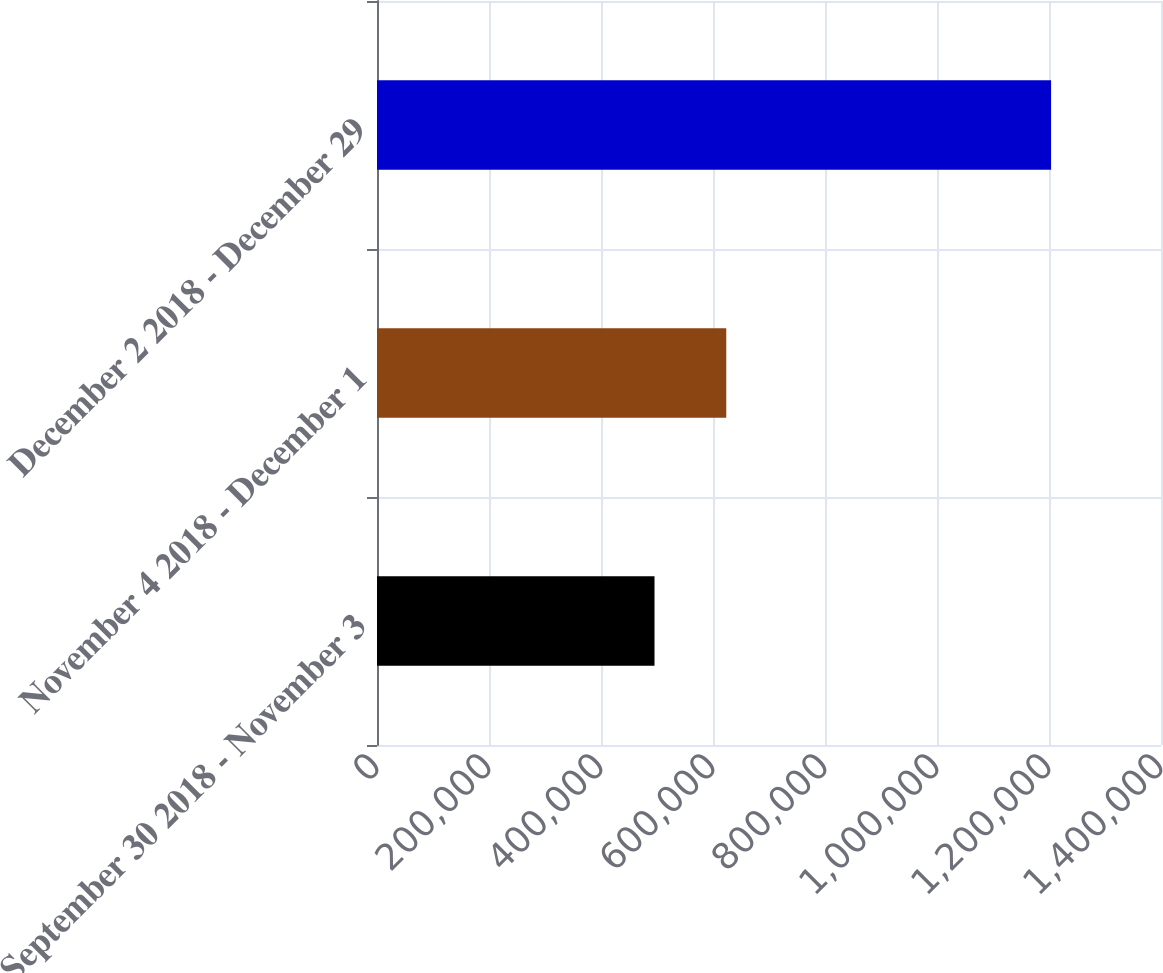Convert chart. <chart><loc_0><loc_0><loc_500><loc_500><bar_chart><fcel>September 30 2018 - November 3<fcel>November 4 2018 - December 1<fcel>December 2 2018 - December 29<nl><fcel>495543<fcel>623692<fcel>1.20369e+06<nl></chart> 